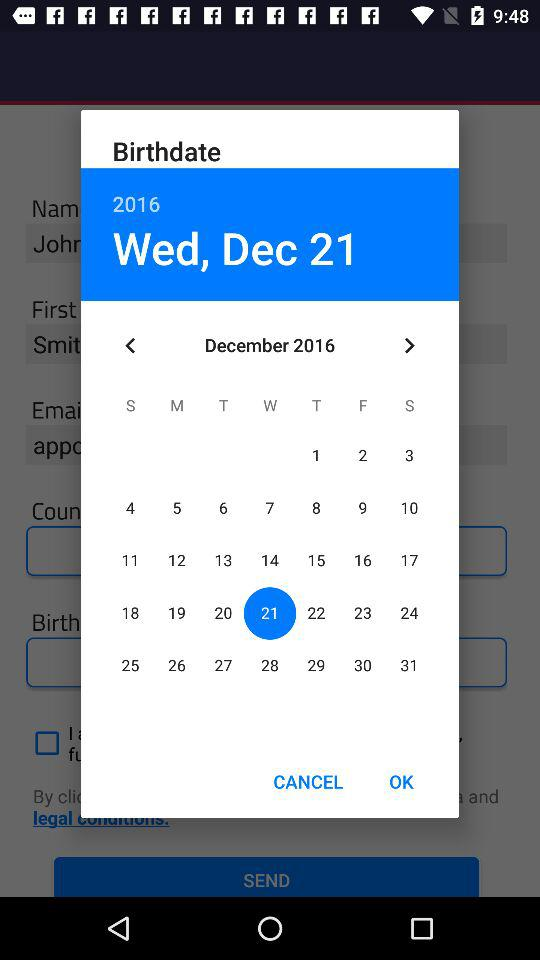What day is it on December 21st? The day is Wednesday. 